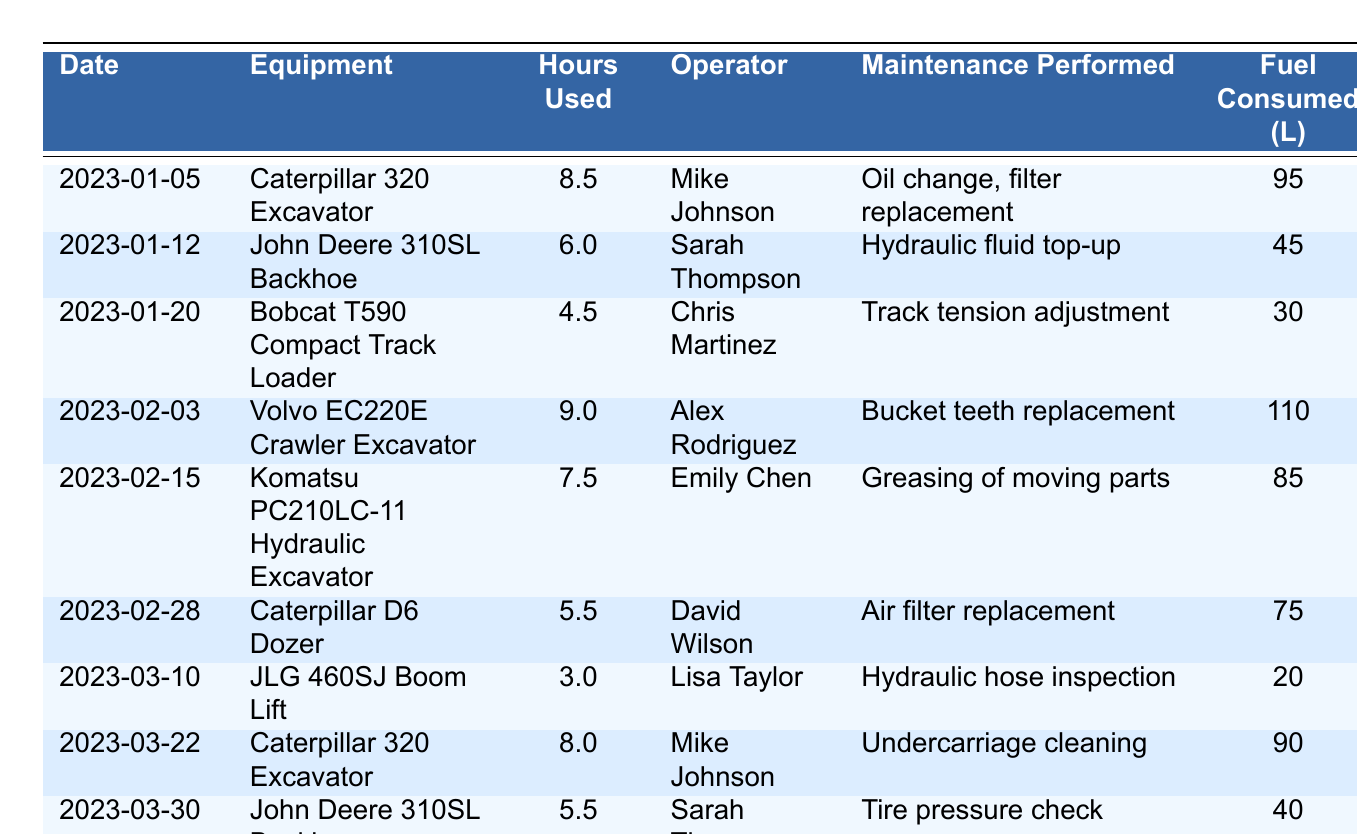What equipment was used the most hours in the logs? The equipment with the highest hours used is the Volvo EC220E Crawler Excavator, used for 9.0 hours on February 3, 2023.
Answer: Volvo EC220E Crawler Excavator How many liters of fuel were consumed by the Caterpillar 320 Excavator? The Caterpillar 320 Excavator was used on two dates: January 5 (95 liters) and March 22 (90 liters). Adding these gives 95 + 90 = 185 liters.
Answer: 185 liters Who performed the maintenance on the Bobcat T590 Compact Track Loader? The maintenance on the Bobcat T590 Compact Track Loader was performed by Chris Martinez on January 20, 2023.
Answer: Chris Martinez Did the John Deere 310SL Backhoe require any maintenance on March 30? Yes, on March 30, 2023, it required a tire pressure check according to the logs.
Answer: Yes What is the total number of hours all equipment was used in January? Summing the hours used in January gives: 8.5 (Caterpillar) + 6.0 (John Deere) + 4.5 (Bobcat) = 19.0 hours.
Answer: 19.0 hours How many times was the Caterpillar D6 Dozer operated? The Caterpillar D6 Dozer was operated once on February 28, 2023.
Answer: Once What is the average fuel consumption for the equipment logged in February? The total fuel consumed in February is 110 (Volvo) + 85 (Komatsu) + 75 (Caterpillar) = 270 liters, and there were 3 logs; thus, the average is 270 / 3 = 90 liters.
Answer: 90 liters Which operator performed the most maintenance tasks? Mike Johnson operated the Caterpillar 320 Excavator twice, indicating he performed the most maintenance tasks from the logs.
Answer: Mike Johnson What was the total maintenance tasks recorded for January? In January, two tasks were recorded: an oil change and filter replacement on January 5, and a hydraulic fluid top-up on January 12, totaling 2 maintenance tasks.
Answer: 2 tasks Was there any hydraulic maintenance done in March? Yes, on March 10, 2023, hydraulic hose inspection was performed on the JLG 460SJ Boom Lift.
Answer: Yes 